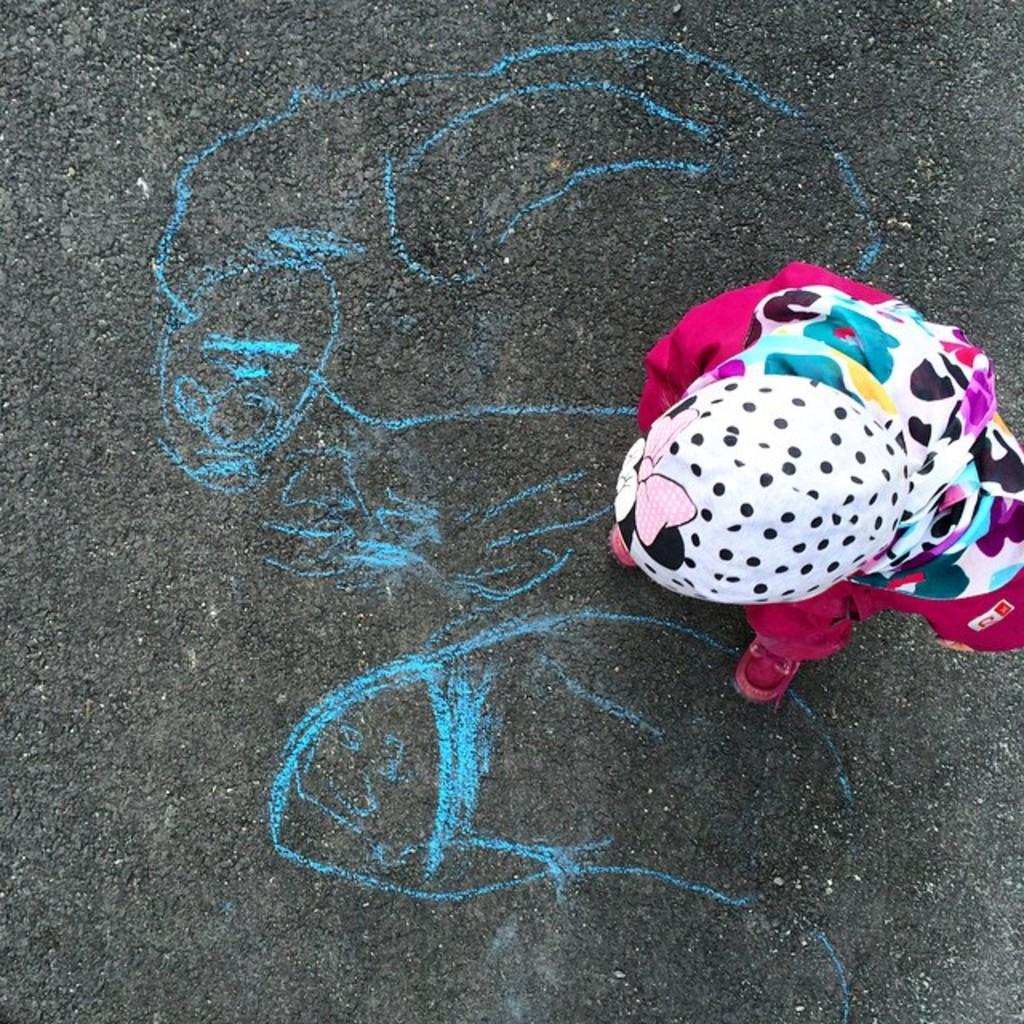What is the person in the image doing? The person is standing on the road. What can be seen on the road in front of the person? There is a drawing on the road in front of the person. What type of furniture is present in the person's home in the image? There is no information about a home or furniture in the image; it only shows a person standing on the road with a drawing on it. 